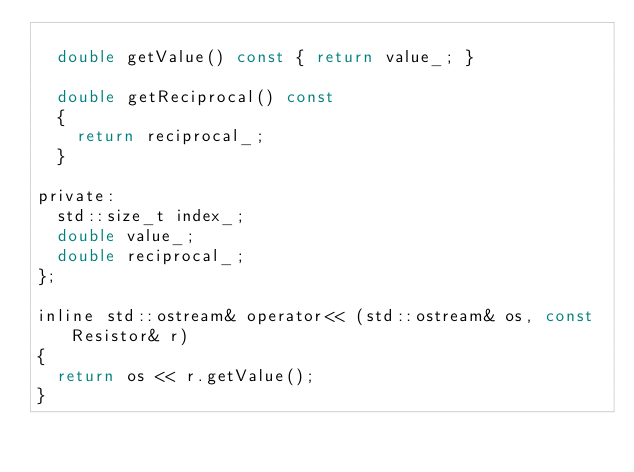<code> <loc_0><loc_0><loc_500><loc_500><_C_>
	double getValue() const { return value_; }

	double getReciprocal() const
	{
		return reciprocal_;
	}

private:
	std::size_t index_;
	double value_;
	double reciprocal_;
};

inline std::ostream& operator<< (std::ostream& os, const Resistor& r)
{
	return os << r.getValue();
}</code> 